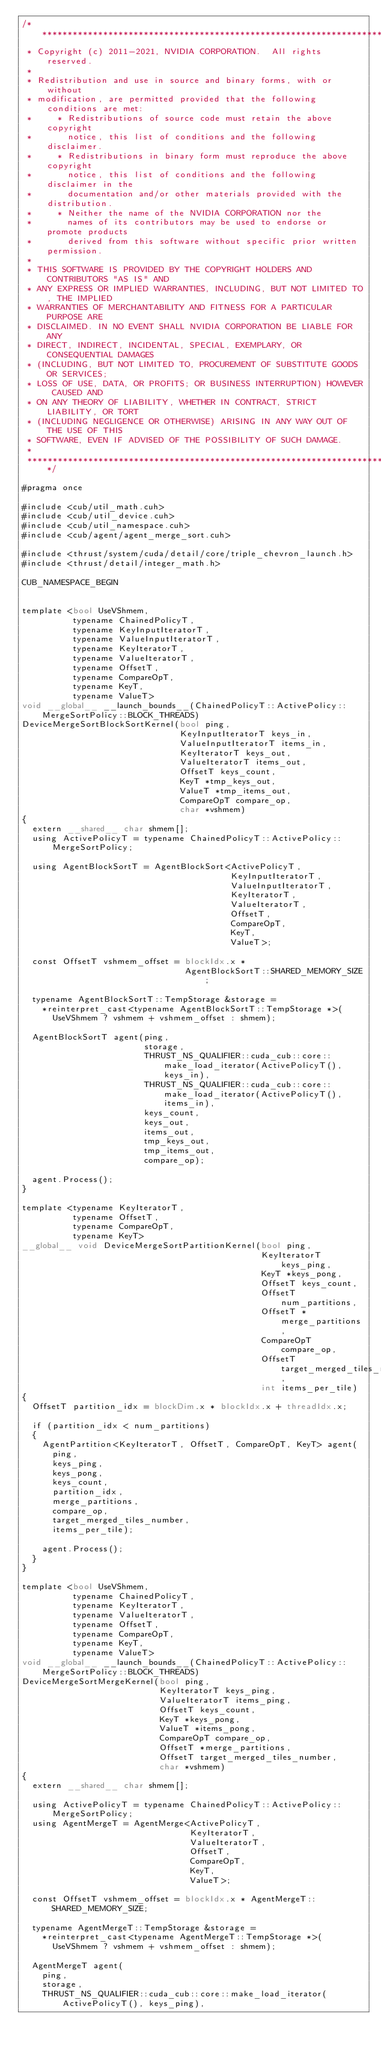<code> <loc_0><loc_0><loc_500><loc_500><_Cuda_>/******************************************************************************
 * Copyright (c) 2011-2021, NVIDIA CORPORATION.  All rights reserved.
 *
 * Redistribution and use in source and binary forms, with or without
 * modification, are permitted provided that the following conditions are met:
 *     * Redistributions of source code must retain the above copyright
 *       notice, this list of conditions and the following disclaimer.
 *     * Redistributions in binary form must reproduce the above copyright
 *       notice, this list of conditions and the following disclaimer in the
 *       documentation and/or other materials provided with the distribution.
 *     * Neither the name of the NVIDIA CORPORATION nor the
 *       names of its contributors may be used to endorse or promote products
 *       derived from this software without specific prior written permission.
 *
 * THIS SOFTWARE IS PROVIDED BY THE COPYRIGHT HOLDERS AND CONTRIBUTORS "AS IS" AND
 * ANY EXPRESS OR IMPLIED WARRANTIES, INCLUDING, BUT NOT LIMITED TO, THE IMPLIED
 * WARRANTIES OF MERCHANTABILITY AND FITNESS FOR A PARTICULAR PURPOSE ARE
 * DISCLAIMED. IN NO EVENT SHALL NVIDIA CORPORATION BE LIABLE FOR ANY
 * DIRECT, INDIRECT, INCIDENTAL, SPECIAL, EXEMPLARY, OR CONSEQUENTIAL DAMAGES
 * (INCLUDING, BUT NOT LIMITED TO, PROCUREMENT OF SUBSTITUTE GOODS OR SERVICES;
 * LOSS OF USE, DATA, OR PROFITS; OR BUSINESS INTERRUPTION) HOWEVER CAUSED AND
 * ON ANY THEORY OF LIABILITY, WHETHER IN CONTRACT, STRICT LIABILITY, OR TORT
 * (INCLUDING NEGLIGENCE OR OTHERWISE) ARISING IN ANY WAY OUT OF THE USE OF THIS
 * SOFTWARE, EVEN IF ADVISED OF THE POSSIBILITY OF SUCH DAMAGE.
 *
 ******************************************************************************/

#pragma once

#include <cub/util_math.cuh>
#include <cub/util_device.cuh>
#include <cub/util_namespace.cuh>
#include <cub/agent/agent_merge_sort.cuh>

#include <thrust/system/cuda/detail/core/triple_chevron_launch.h>
#include <thrust/detail/integer_math.h>

CUB_NAMESPACE_BEGIN


template <bool UseVShmem,
          typename ChainedPolicyT,
          typename KeyInputIteratorT,
          typename ValueInputIteratorT,
          typename KeyIteratorT,
          typename ValueIteratorT,
          typename OffsetT,
          typename CompareOpT,
          typename KeyT,
          typename ValueT>
void __global__ __launch_bounds__(ChainedPolicyT::ActivePolicy::MergeSortPolicy::BLOCK_THREADS)
DeviceMergeSortBlockSortKernel(bool ping,
                               KeyInputIteratorT keys_in,
                               ValueInputIteratorT items_in,
                               KeyIteratorT keys_out,
                               ValueIteratorT items_out,
                               OffsetT keys_count,
                               KeyT *tmp_keys_out,
                               ValueT *tmp_items_out,
                               CompareOpT compare_op,
                               char *vshmem)
{
  extern __shared__ char shmem[];
  using ActivePolicyT = typename ChainedPolicyT::ActivePolicy::MergeSortPolicy;

  using AgentBlockSortT = AgentBlockSort<ActivePolicyT,
                                         KeyInputIteratorT,
                                         ValueInputIteratorT,
                                         KeyIteratorT,
                                         ValueIteratorT,
                                         OffsetT,
                                         CompareOpT,
                                         KeyT,
                                         ValueT>;

  const OffsetT vshmem_offset = blockIdx.x *
                                AgentBlockSortT::SHARED_MEMORY_SIZE;

  typename AgentBlockSortT::TempStorage &storage =
    *reinterpret_cast<typename AgentBlockSortT::TempStorage *>(
      UseVShmem ? vshmem + vshmem_offset : shmem);

  AgentBlockSortT agent(ping,
                        storage,
                        THRUST_NS_QUALIFIER::cuda_cub::core::make_load_iterator(ActivePolicyT(), keys_in),
                        THRUST_NS_QUALIFIER::cuda_cub::core::make_load_iterator(ActivePolicyT(), items_in),
                        keys_count,
                        keys_out,
                        items_out,
                        tmp_keys_out,
                        tmp_items_out,
                        compare_op);

  agent.Process();
}

template <typename KeyIteratorT,
          typename OffsetT,
          typename CompareOpT,
          typename KeyT>
__global__ void DeviceMergeSortPartitionKernel(bool ping,
                                               KeyIteratorT keys_ping,
                                               KeyT *keys_pong,
                                               OffsetT keys_count,
                                               OffsetT num_partitions,
                                               OffsetT *merge_partitions,
                                               CompareOpT compare_op,
                                               OffsetT target_merged_tiles_number,
                                               int items_per_tile)
{
  OffsetT partition_idx = blockDim.x * blockIdx.x + threadIdx.x;

  if (partition_idx < num_partitions)
  {
    AgentPartition<KeyIteratorT, OffsetT, CompareOpT, KeyT> agent(
      ping,
      keys_ping,
      keys_pong,
      keys_count,
      partition_idx,
      merge_partitions,
      compare_op,
      target_merged_tiles_number,
      items_per_tile);

    agent.Process();
  }
}

template <bool UseVShmem,
          typename ChainedPolicyT,
          typename KeyIteratorT,
          typename ValueIteratorT,
          typename OffsetT,
          typename CompareOpT,
          typename KeyT,
          typename ValueT>
void __global__ __launch_bounds__(ChainedPolicyT::ActivePolicy::MergeSortPolicy::BLOCK_THREADS)
DeviceMergeSortMergeKernel(bool ping,
                           KeyIteratorT keys_ping,
                           ValueIteratorT items_ping,
                           OffsetT keys_count,
                           KeyT *keys_pong,
                           ValueT *items_pong,
                           CompareOpT compare_op,
                           OffsetT *merge_partitions,
                           OffsetT target_merged_tiles_number,
                           char *vshmem)
{
  extern __shared__ char shmem[];

  using ActivePolicyT = typename ChainedPolicyT::ActivePolicy::MergeSortPolicy;
  using AgentMergeT = AgentMerge<ActivePolicyT,
                                 KeyIteratorT,
                                 ValueIteratorT,
                                 OffsetT,
                                 CompareOpT,
                                 KeyT,
                                 ValueT>;

  const OffsetT vshmem_offset = blockIdx.x * AgentMergeT::SHARED_MEMORY_SIZE;

  typename AgentMergeT::TempStorage &storage =
    *reinterpret_cast<typename AgentMergeT::TempStorage *>(
      UseVShmem ? vshmem + vshmem_offset : shmem);

  AgentMergeT agent(
    ping,
    storage,
    THRUST_NS_QUALIFIER::cuda_cub::core::make_load_iterator(ActivePolicyT(), keys_ping),</code> 